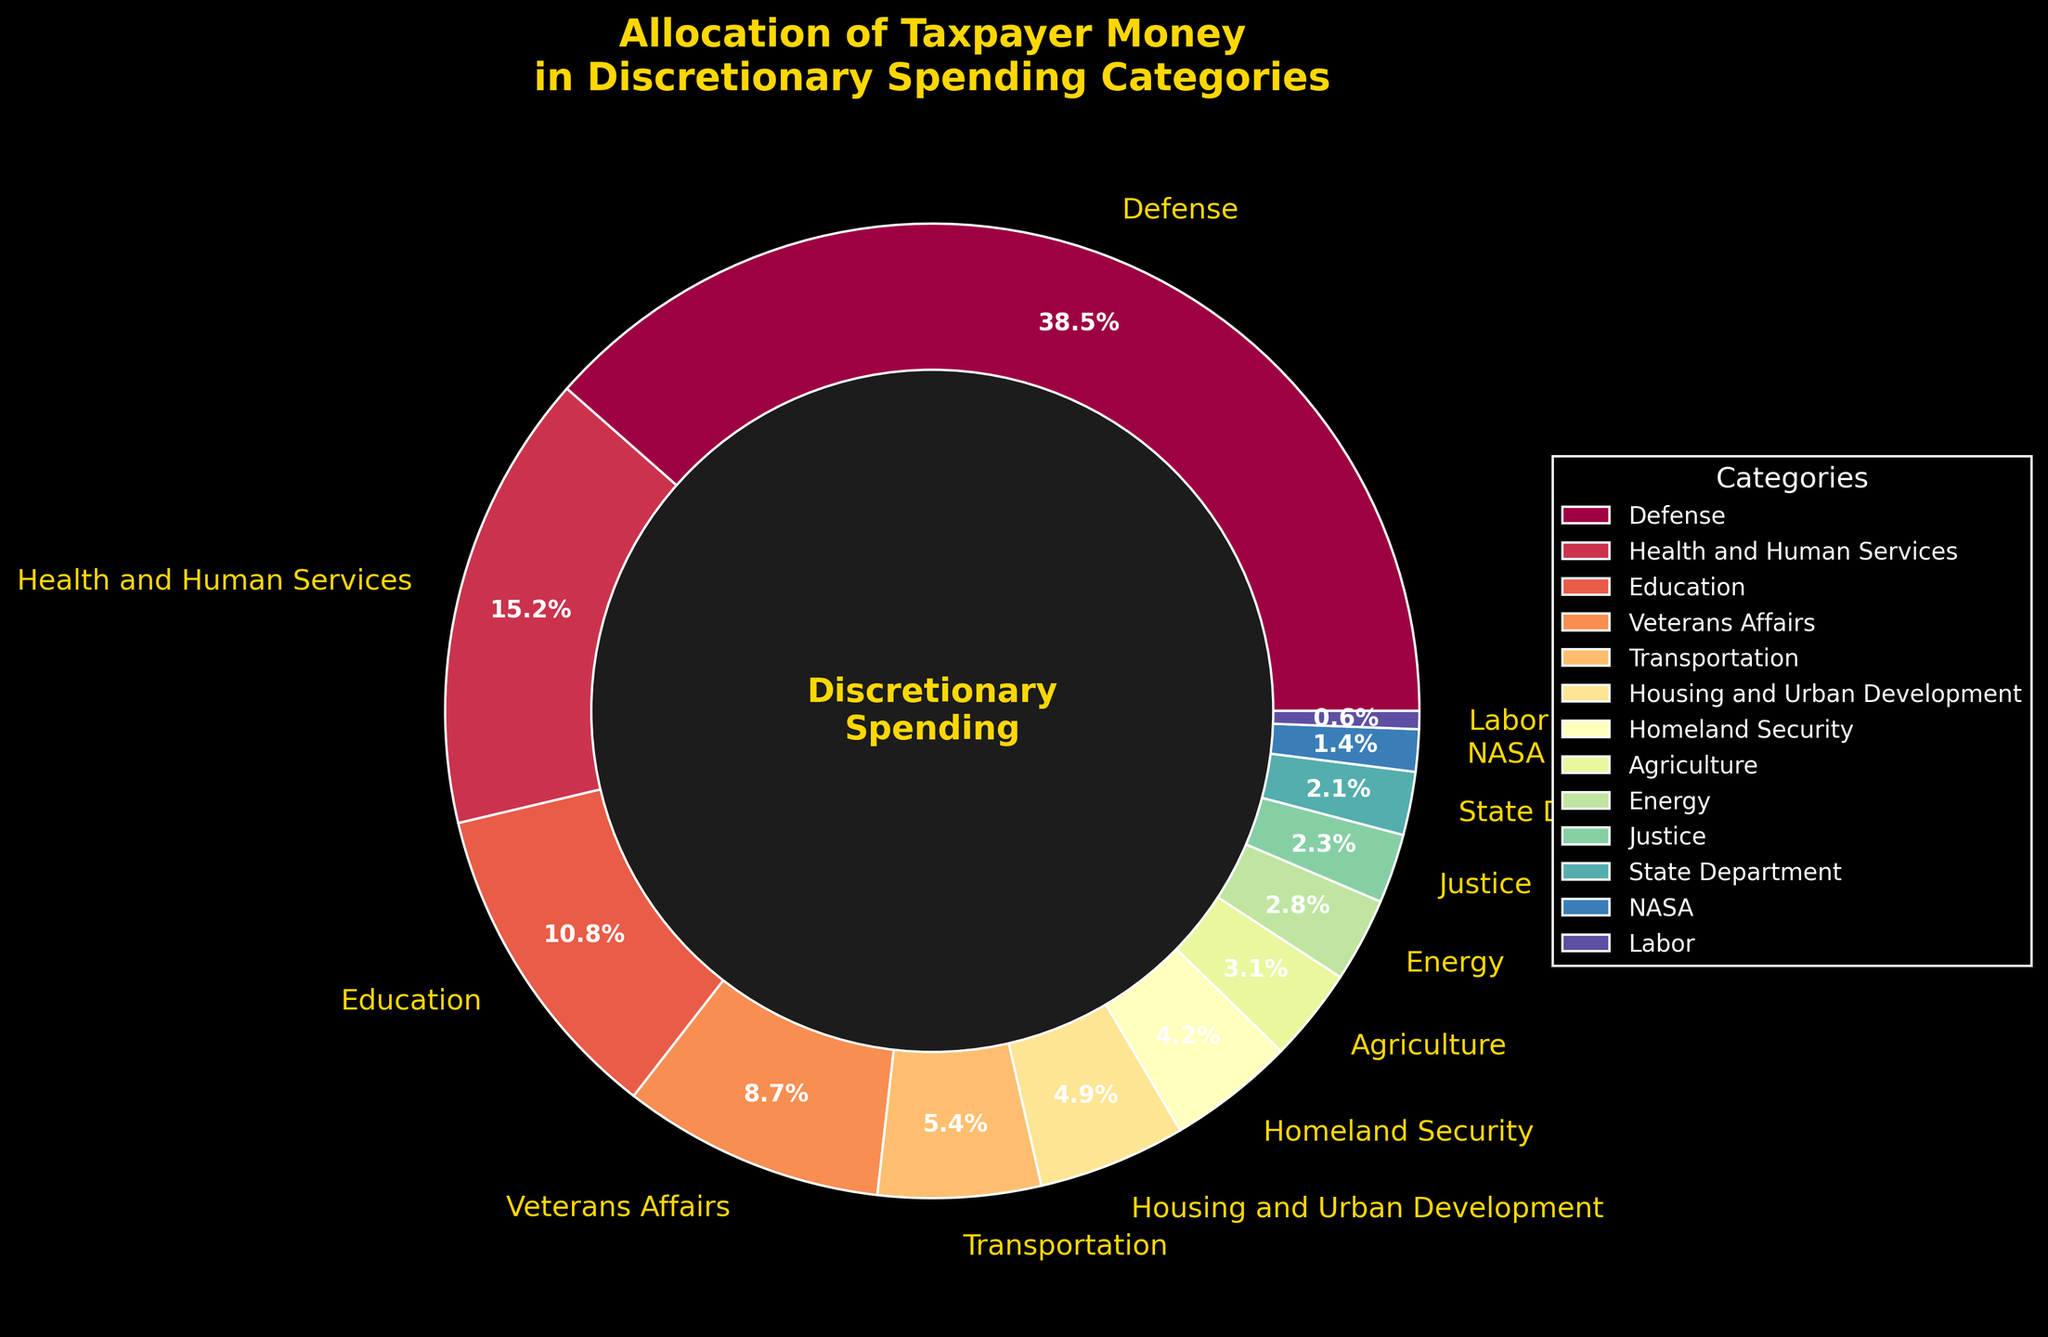Which category receives the largest allocation of taxpayer money? The largest wedge in the pie chart represents the category with the highest percentage. This category can be identified by examining which slice visually appears largest or has the highest numerical percentage.
Answer: Defense What is the combined percentage of taxpayer money allocated to Health and Human Services and Education? Sum the percentages of Health and Human Services (15.2%) and Education (10.8%). 15.2 + 10.8 = 26.0
Answer: 26.0% Which category receives a lower percentage of funding: Transportation or Housing and Urban Development? Compare the percentages of Transportation (5.4%) and Housing and Urban Development (4.9%) and determine which is smaller. 4.9 < 5.4
Answer: Housing and Urban Development How much more percentage of taxpayer money is allocated to Defense than to Education? Subtract the percentage allocated to Education (10.8%) from the percentage allocated to Defense (38.5%). 38.5 - 10.8 = 27.7
Answer: 27.7% Which category has a larger allocation, Agriculture or Homeland Security? Compare the percentages of Agriculture (3.1%) and Homeland Security (4.2%). 4.2 > 3.1
Answer: Homeland Security Which categories have allocations less than 5%? Identify all categories that have percentages below 5% by examining the pie chart: Housing and Urban Development (4.9%), Homeland Security (4.2%), Agriculture (3.1%), Energy (2.8%), Justice (2.3%), State Department (2.1%), NASA (1.4%), Labor (0.6%).
Answer: Housing and Urban Development, Homeland Security, Agriculture, Energy, Justice, State Department, NASA, Labor What is the percentage difference between Veterans Affairs and Health and Human Services? Subtract the percentage of Veterans Affairs (8.7%) from Health and Human Services (15.2%). 15.2 - 8.7 = 6.5
Answer: 6.5% Which category receives the smallest allocation of taxpayer money, and what is its percentage? Look for the category with the smallest wedge and its corresponding percentage in the pie chart.
Answer: Labor, 0.6% Does the State Department receive more or less funding than Justice? Compare the percentages of the State Department (2.1%) and Justice (2.3%). 2.1 < 2.3
Answer: Less What is the total percentage of discretionary spending allocated to Defense, Health and Human Services, and Education combined? Sum the percentages of Defense (38.5%), Health and Human Services (15.2%), and Education (10.8%). 38.5 + 15.2 + 10.8 = 64.5
Answer: 64.5% 